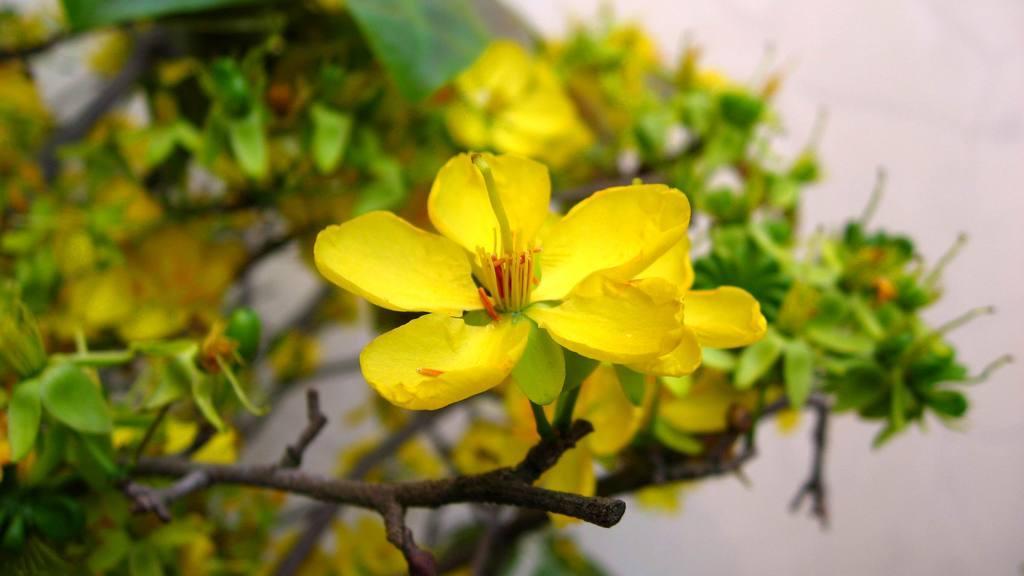Describe this image in one or two sentences. In this image I can see flowering plants. In the background I can see a wall. This image is taken may be in a garden. 